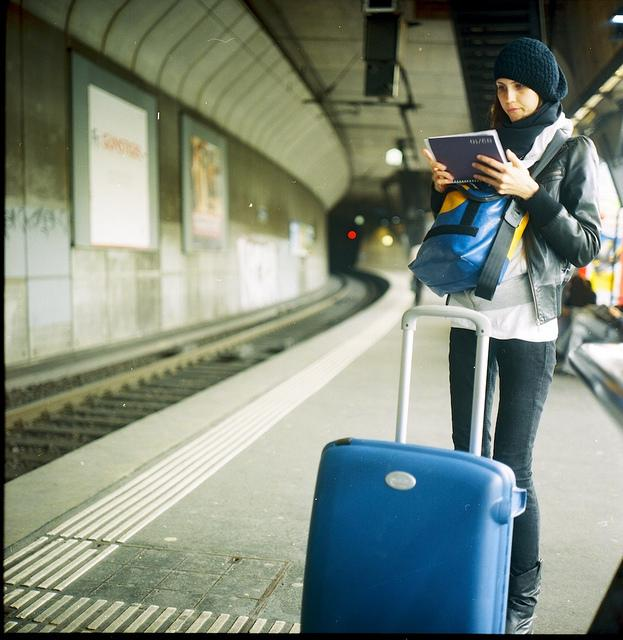What is the best luggage brand in the world? samsonite 